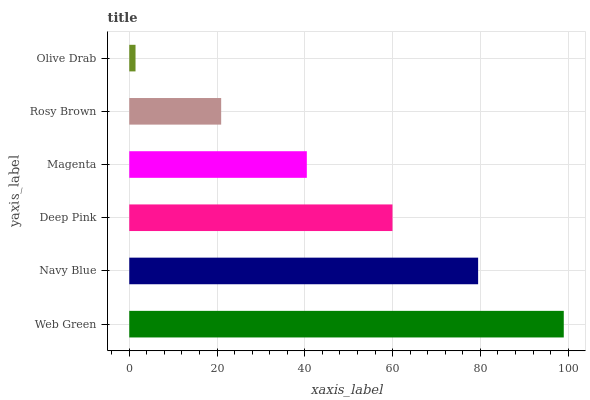Is Olive Drab the minimum?
Answer yes or no. Yes. Is Web Green the maximum?
Answer yes or no. Yes. Is Navy Blue the minimum?
Answer yes or no. No. Is Navy Blue the maximum?
Answer yes or no. No. Is Web Green greater than Navy Blue?
Answer yes or no. Yes. Is Navy Blue less than Web Green?
Answer yes or no. Yes. Is Navy Blue greater than Web Green?
Answer yes or no. No. Is Web Green less than Navy Blue?
Answer yes or no. No. Is Deep Pink the high median?
Answer yes or no. Yes. Is Magenta the low median?
Answer yes or no. Yes. Is Rosy Brown the high median?
Answer yes or no. No. Is Olive Drab the low median?
Answer yes or no. No. 